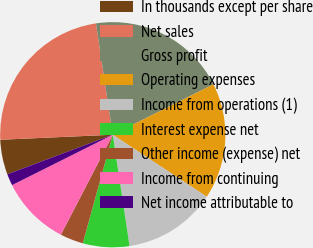Convert chart to OTSL. <chart><loc_0><loc_0><loc_500><loc_500><pie_chart><fcel>In thousands except per share<fcel>Net sales<fcel>Gross profit<fcel>Operating expenses<fcel>Income from operations (1)<fcel>Interest expense net<fcel>Other income (expense) net<fcel>Income from continuing<fcel>Net income attributable to<nl><fcel>5.0%<fcel>23.33%<fcel>20.0%<fcel>16.67%<fcel>13.33%<fcel>6.67%<fcel>3.33%<fcel>10.0%<fcel>1.67%<nl></chart> 